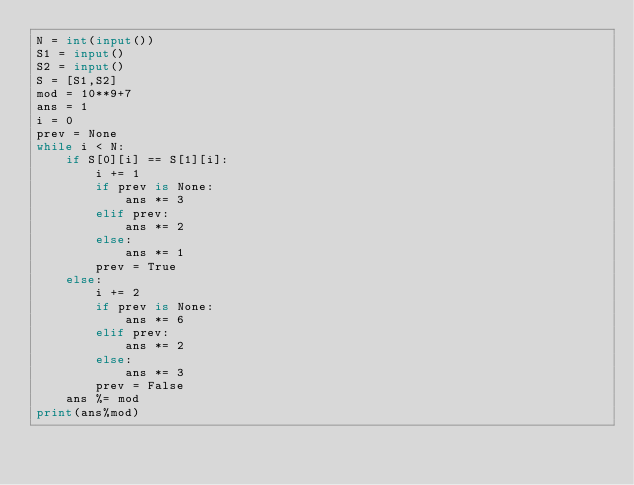<code> <loc_0><loc_0><loc_500><loc_500><_Python_>N = int(input())
S1 = input()
S2 = input()
S = [S1,S2]
mod = 10**9+7
ans = 1
i = 0
prev = None
while i < N:
    if S[0][i] == S[1][i]:
        i += 1
        if prev is None:
            ans *= 3
        elif prev:
            ans *= 2
        else:
            ans *= 1
        prev = True
    else:
        i += 2
        if prev is None:
            ans *= 6
        elif prev:
            ans *= 2
        else:
            ans *= 3
        prev = False
    ans %= mod
print(ans%mod)</code> 